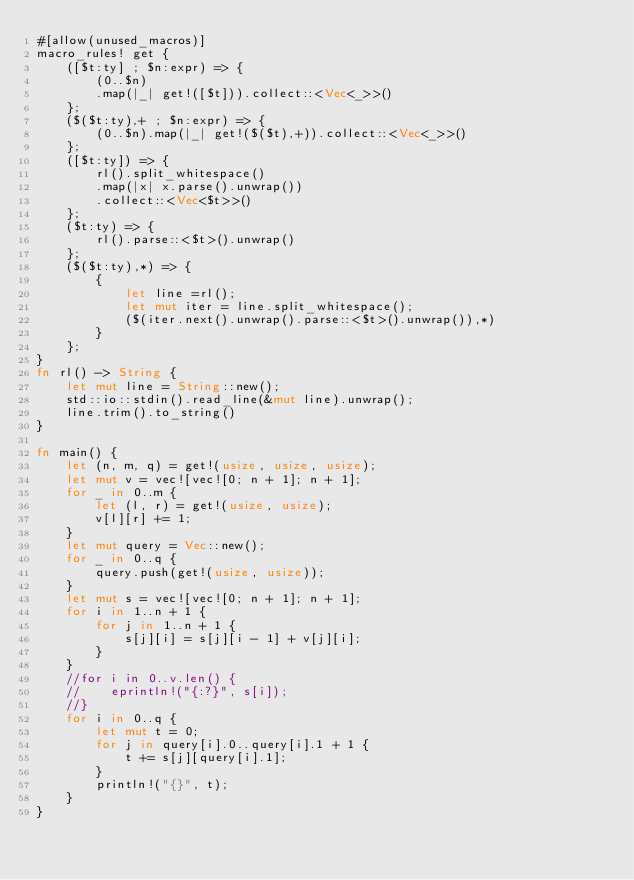<code> <loc_0><loc_0><loc_500><loc_500><_Rust_>#[allow(unused_macros)]
macro_rules! get {
    ([$t:ty] ; $n:expr) => {
        (0..$n)
        .map(|_| get!([$t])).collect::<Vec<_>>()
    };
    ($($t:ty),+ ; $n:expr) => {
        (0..$n).map(|_| get!($($t),+)).collect::<Vec<_>>()
    };
    ([$t:ty]) => {
        rl().split_whitespace()
        .map(|x| x.parse().unwrap())
        .collect::<Vec<$t>>()
    };
    ($t:ty) => {
        rl().parse::<$t>().unwrap()
    };
    ($($t:ty),*) => {
        {
            let line =rl();
            let mut iter = line.split_whitespace();
            ($(iter.next().unwrap().parse::<$t>().unwrap()),*)
        }
    };
}
fn rl() -> String {
    let mut line = String::new();
    std::io::stdin().read_line(&mut line).unwrap();
    line.trim().to_string()
}

fn main() {
    let (n, m, q) = get!(usize, usize, usize);
    let mut v = vec![vec![0; n + 1]; n + 1];
    for _ in 0..m {
        let (l, r) = get!(usize, usize);
        v[l][r] += 1;
    }
    let mut query = Vec::new();
    for _ in 0..q {
        query.push(get!(usize, usize));
    }
    let mut s = vec![vec![0; n + 1]; n + 1];
    for i in 1..n + 1 {
        for j in 1..n + 1 {
            s[j][i] = s[j][i - 1] + v[j][i];
        }
    }
    //for i in 0..v.len() {
    //    eprintln!("{:?}", s[i]);
    //}
    for i in 0..q {
        let mut t = 0;
        for j in query[i].0..query[i].1 + 1 {
            t += s[j][query[i].1];
        }
        println!("{}", t);
    }
}
</code> 